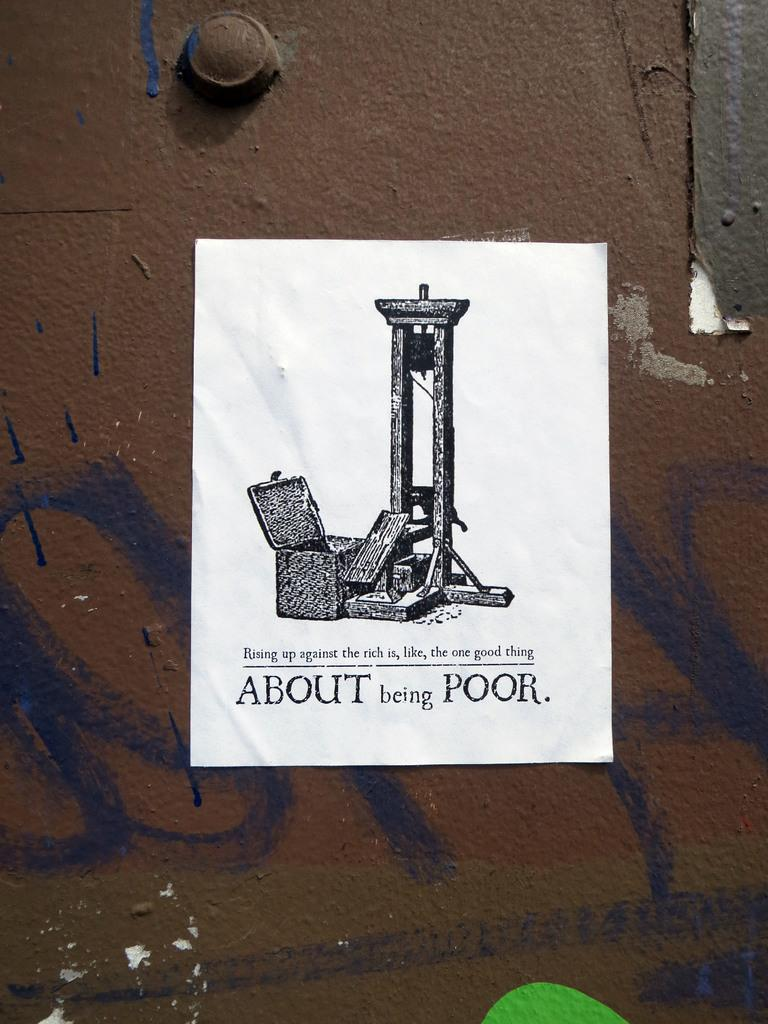<image>
Give a short and clear explanation of the subsequent image. a paper that says about being poor on it 